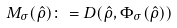<formula> <loc_0><loc_0><loc_500><loc_500>M _ { \sigma } ( { \hat { \rho } } ) \colon = D ( { \hat { \rho } } , \Phi _ { \sigma } ( { \hat { \rho } } ) )</formula> 